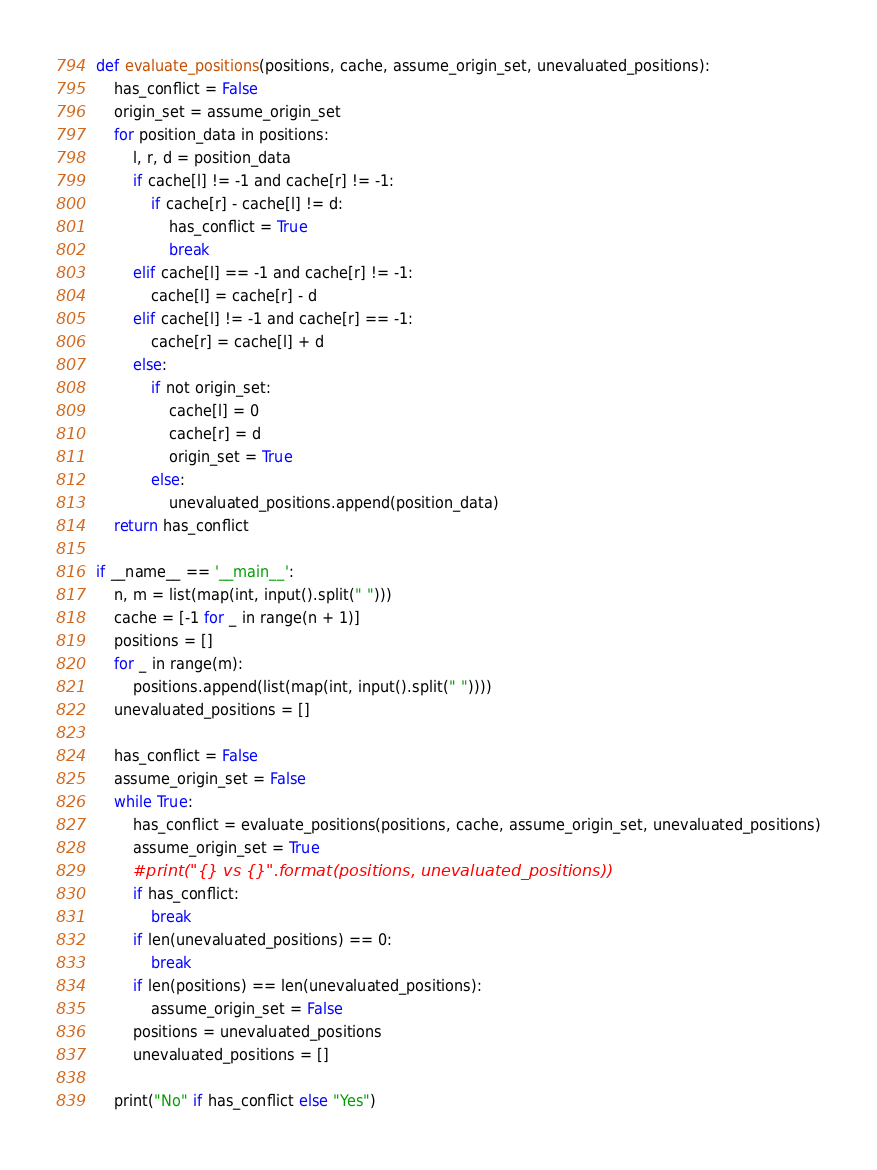<code> <loc_0><loc_0><loc_500><loc_500><_Python_>def evaluate_positions(positions, cache, assume_origin_set, unevaluated_positions):
    has_conflict = False
    origin_set = assume_origin_set
    for position_data in positions:
        l, r, d = position_data
        if cache[l] != -1 and cache[r] != -1:
            if cache[r] - cache[l] != d:
                has_conflict = True
                break
        elif cache[l] == -1 and cache[r] != -1:
            cache[l] = cache[r] - d
        elif cache[l] != -1 and cache[r] == -1:
            cache[r] = cache[l] + d
        else:
            if not origin_set:
                cache[l] = 0
                cache[r] = d
                origin_set = True
            else:
                unevaluated_positions.append(position_data)
    return has_conflict

if __name__ == '__main__':
    n, m = list(map(int, input().split(" ")))
    cache = [-1 for _ in range(n + 1)]
    positions = []
    for _ in range(m):
        positions.append(list(map(int, input().split(" "))))
    unevaluated_positions = []

    has_conflict = False
    assume_origin_set = False
    while True:
        has_conflict = evaluate_positions(positions, cache, assume_origin_set, unevaluated_positions)
        assume_origin_set = True
        #print("{} vs {}".format(positions, unevaluated_positions))
        if has_conflict:
            break
        if len(unevaluated_positions) == 0:
            break
        if len(positions) == len(unevaluated_positions):
            assume_origin_set = False
        positions = unevaluated_positions
        unevaluated_positions = []

    print("No" if has_conflict else "Yes")

</code> 